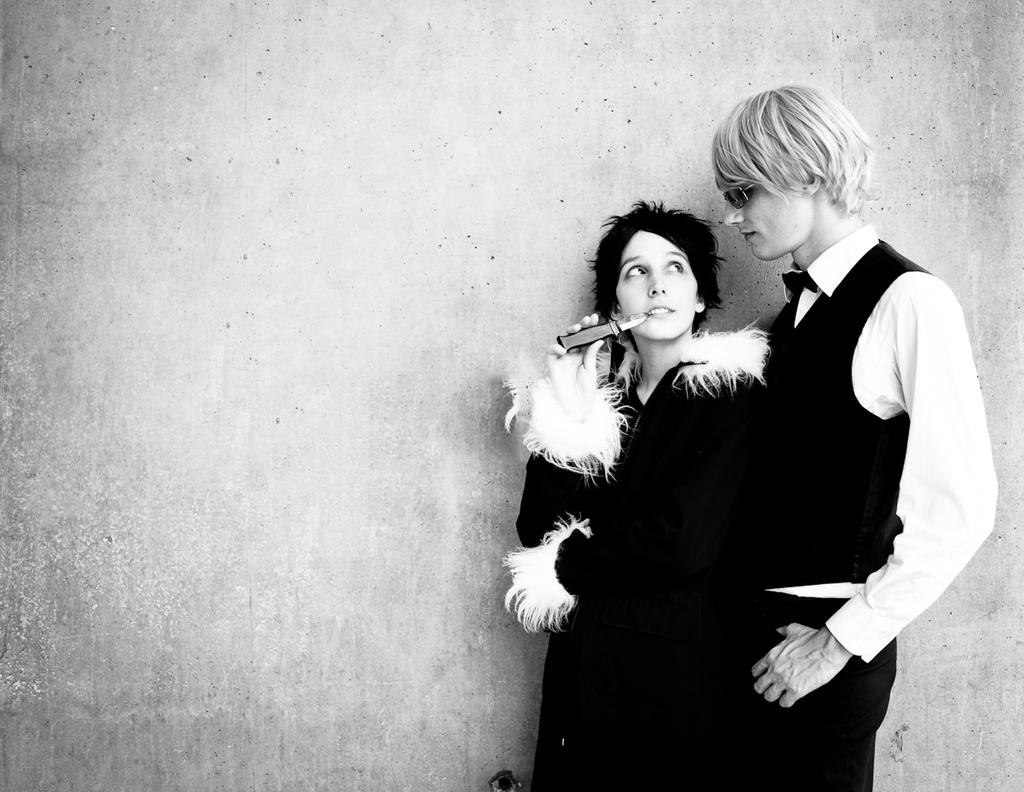Who is present in the image? There is a couple in the image. Where are the couple located in the image? The couple is on the right side of the image. What can be seen in the background of the image? There is a wall in the background of the image. What is the color scheme of the image? The image is black and white. What type of bone is visible in the image? There is no bone present in the image. What pen is the couple using to write in the image? There is no pen visible in the image, and the couple is not shown writing. 